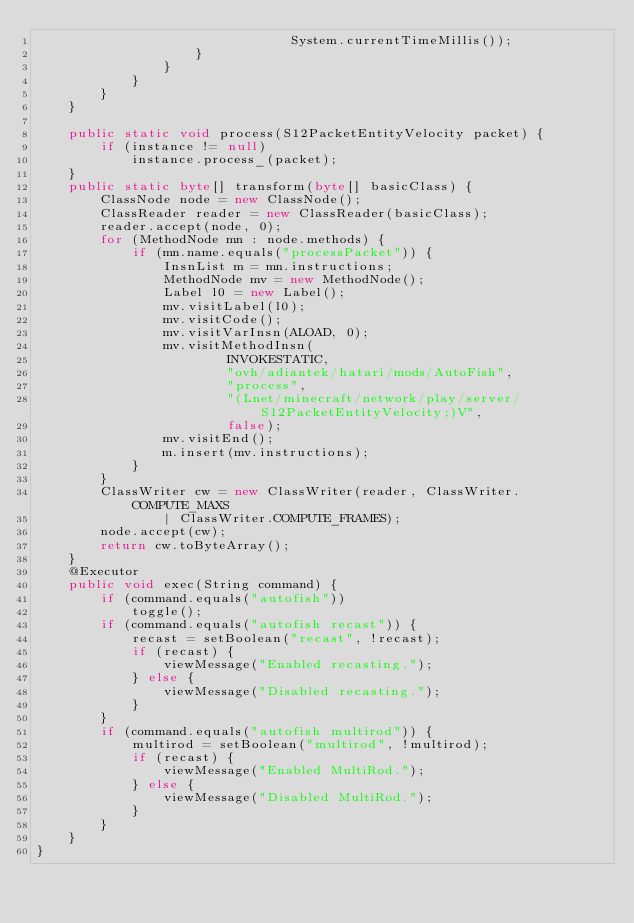Convert code to text. <code><loc_0><loc_0><loc_500><loc_500><_Java_>								System.currentTimeMillis());
					}
				}
			}
		}
	}

	public static void process(S12PacketEntityVelocity packet) {
		if (instance != null)
			instance.process_(packet);
	}
	public static byte[] transform(byte[] basicClass) {
		ClassNode node = new ClassNode();
		ClassReader reader = new ClassReader(basicClass);
		reader.accept(node, 0);
		for (MethodNode mn : node.methods) {
			if (mn.name.equals("processPacket")) {
				InsnList m = mn.instructions;
				MethodNode mv = new MethodNode();
				Label l0 = new Label();
				mv.visitLabel(l0);
				mv.visitCode();
				mv.visitVarInsn(ALOAD, 0);
				mv.visitMethodInsn(
						INVOKESTATIC,
						"ovh/adiantek/hatari/mods/AutoFish",
						"process",
						"(Lnet/minecraft/network/play/server/S12PacketEntityVelocity;)V",
						false);
				mv.visitEnd();
				m.insert(mv.instructions);
			}
		}
		ClassWriter cw = new ClassWriter(reader, ClassWriter.COMPUTE_MAXS
				| ClassWriter.COMPUTE_FRAMES);
		node.accept(cw);
		return cw.toByteArray();
	}
	@Executor
	public void exec(String command) {
		if (command.equals("autofish"))
			toggle();
		if (command.equals("autofish recast")) {
			recast = setBoolean("recast", !recast);
			if (recast) {
				viewMessage("Enabled recasting.");
			} else {
				viewMessage("Disabled recasting.");
			}
		}
		if (command.equals("autofish multirod")) {
			multirod = setBoolean("multirod", !multirod);
			if (recast) {
				viewMessage("Enabled MultiRod.");
			} else {
				viewMessage("Disabled MultiRod.");
			}
		}
	}
}
</code> 